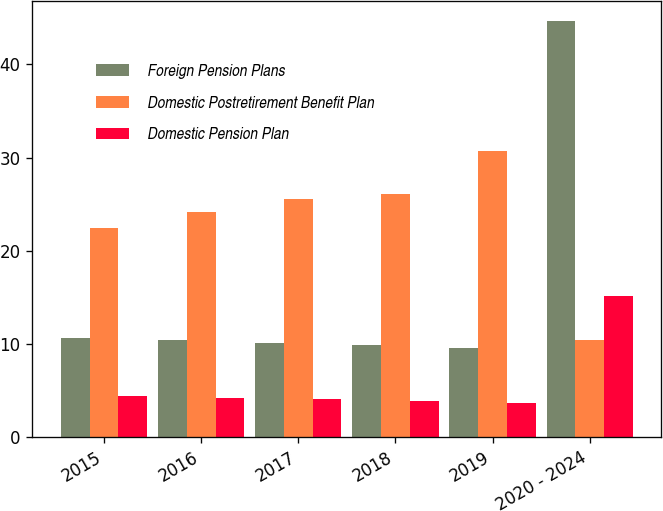<chart> <loc_0><loc_0><loc_500><loc_500><stacked_bar_chart><ecel><fcel>2015<fcel>2016<fcel>2017<fcel>2018<fcel>2019<fcel>2020 - 2024<nl><fcel>Foreign Pension Plans<fcel>10.6<fcel>10.4<fcel>10.1<fcel>9.9<fcel>9.6<fcel>44.6<nl><fcel>Domestic Postretirement Benefit Plan<fcel>22.4<fcel>24.2<fcel>25.6<fcel>26.1<fcel>30.7<fcel>10.4<nl><fcel>Domestic Pension Plan<fcel>4.4<fcel>4.2<fcel>4.1<fcel>3.9<fcel>3.7<fcel>15.1<nl></chart> 